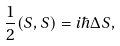Convert formula to latex. <formula><loc_0><loc_0><loc_500><loc_500>\frac { 1 } { 2 } ( S , S ) = i \hbar { \Delta } S ,</formula> 